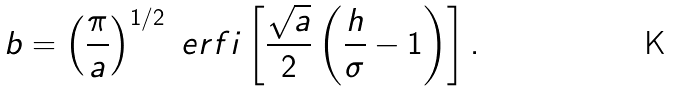<formula> <loc_0><loc_0><loc_500><loc_500>b = \left ( \frac { \pi } { a } \right ) ^ { 1 / 2 } \ e r f i \left [ \frac { \sqrt { a } } { 2 } \left ( \frac { h } { \sigma } - 1 \right ) \right ] .</formula> 